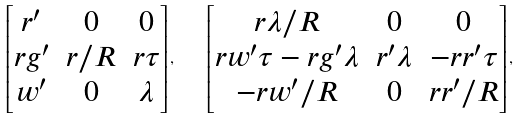<formula> <loc_0><loc_0><loc_500><loc_500>\begin{bmatrix} r ^ { \prime } & 0 & 0 \\ r g ^ { \prime } & r / R & r \tau \\ w ^ { \prime } & 0 & \lambda \end{bmatrix} , \quad \begin{bmatrix} r \lambda / R & 0 & 0 \\ r w ^ { \prime } \tau - r g ^ { \prime } \lambda & r ^ { \prime } \lambda & - r r ^ { \prime } \tau \\ - r w ^ { \prime } / R & 0 & r r ^ { \prime } / R \end{bmatrix} ,</formula> 